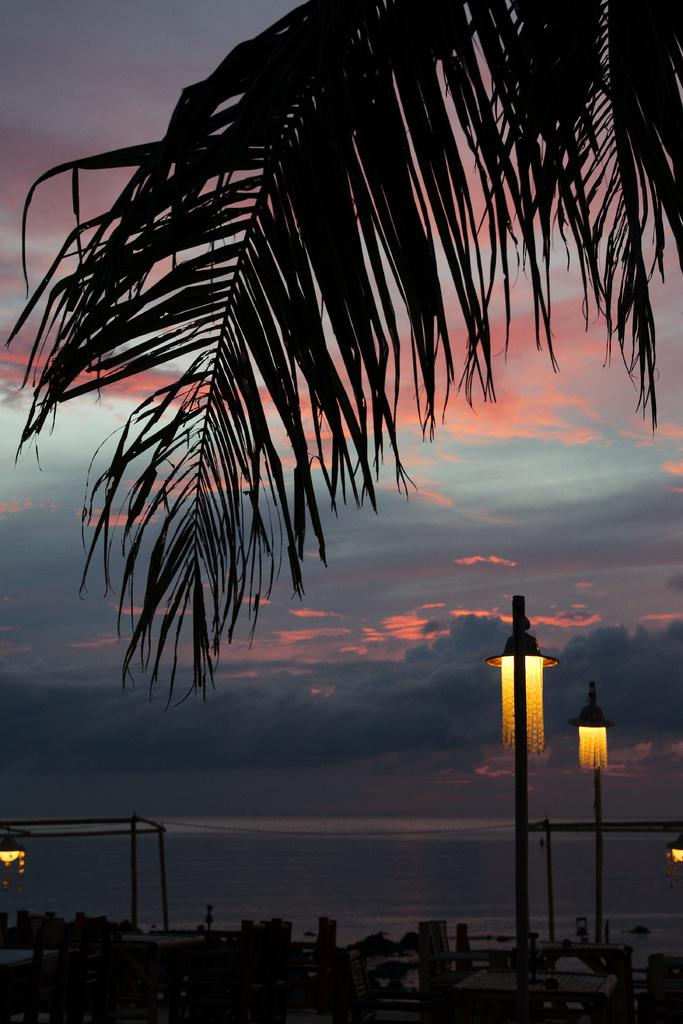What type of natural element is present in the image? There is a tree in the image. What artificial elements can be seen in the image? There are lights and poles in the image. What is visible in the sky in the image? There are clouds visible in the image. Can you tell me how many mice are hiding in the tree in the image? There are no mice present in the image; it features a tree, lights, and poles. What type of button can be seen on the drawer in the image? There is no drawer or button present in the image. 